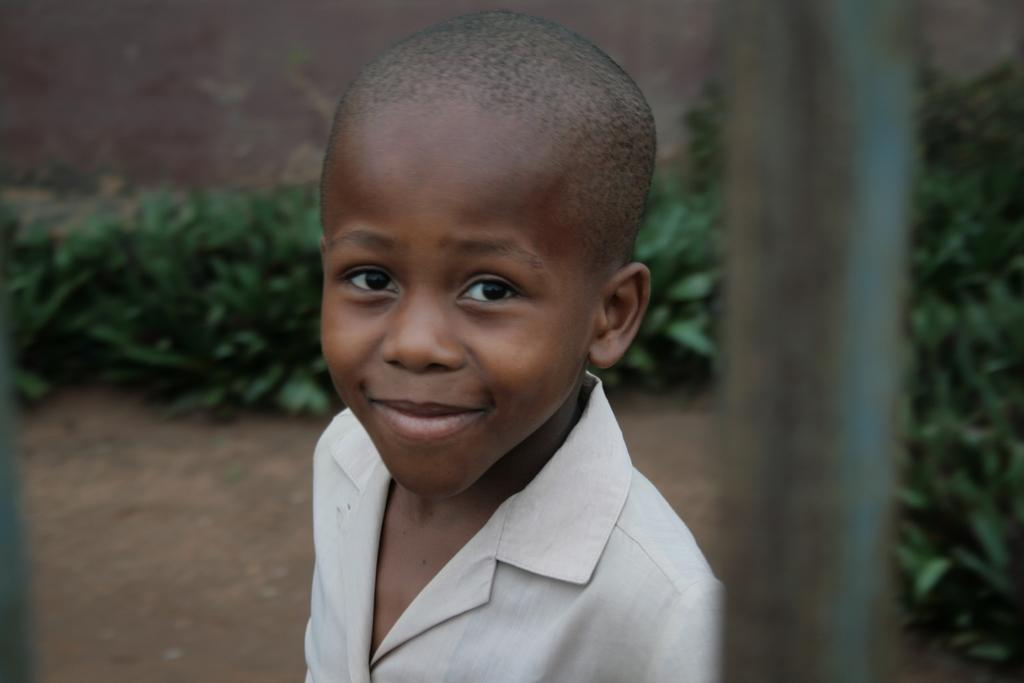Who is the main subject in the image? There is a boy in the image. What is the boy wearing? The boy is wearing a shirt. What can be seen in the background of the image? There are plants on the land in the background. What object is located on the right side of the image? There is a pole on the right side of the image. How does the boy change the wax in the image? There is no wax present in the image, so the boy cannot change it. 